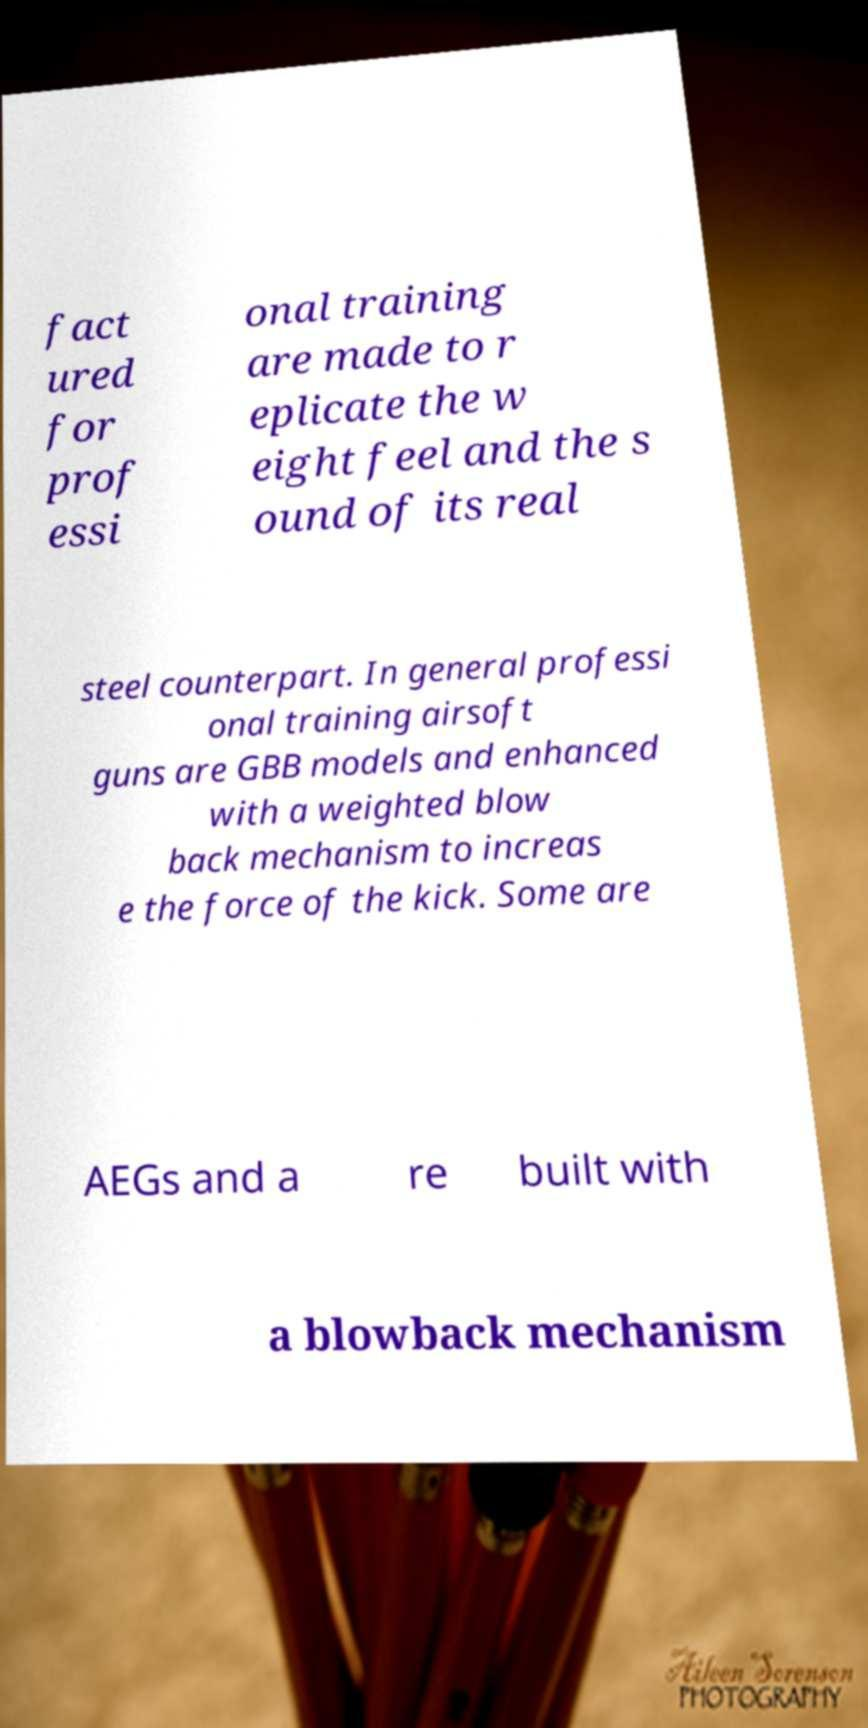I need the written content from this picture converted into text. Can you do that? fact ured for prof essi onal training are made to r eplicate the w eight feel and the s ound of its real steel counterpart. In general professi onal training airsoft guns are GBB models and enhanced with a weighted blow back mechanism to increas e the force of the kick. Some are AEGs and a re built with a blowback mechanism 